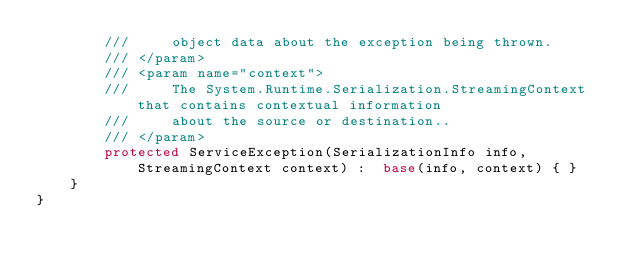<code> <loc_0><loc_0><loc_500><loc_500><_C#_>        ///     object data about the exception being thrown.
        /// </param>
        /// <param name="context">
        ///     The System.Runtime.Serialization.StreamingContext that contains contextual information
        ///     about the source or destination..
        /// </param>
        protected ServiceException(SerializationInfo info, StreamingContext context) :  base(info, context) { }
    }
}</code> 